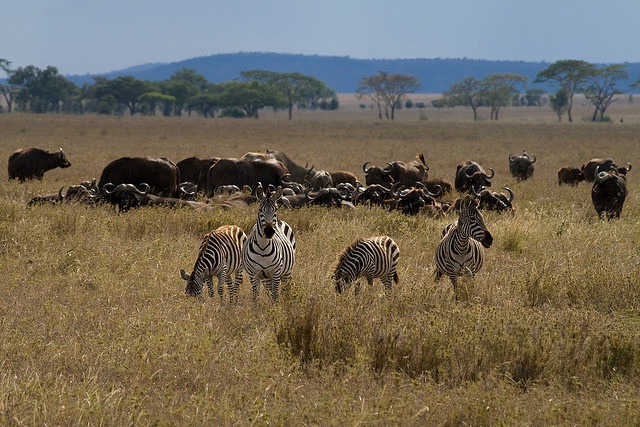Describe the objects in this image and their specific colors. I can see cow in darkgray, black, olive, and gray tones, zebra in darkgray, black, and gray tones, zebra in darkgray, black, and gray tones, zebra in darkgray, black, and gray tones, and zebra in darkgray, black, and gray tones in this image. 